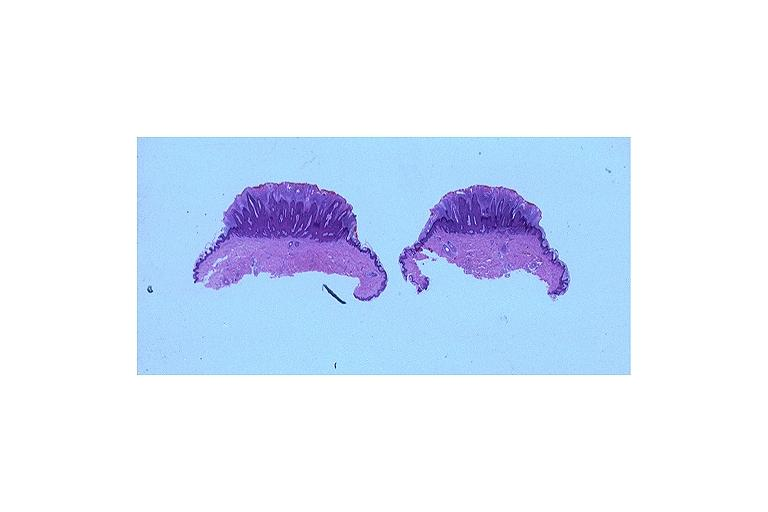what does this image show?
Answer the question using a single word or phrase. Verruca vulgaris 